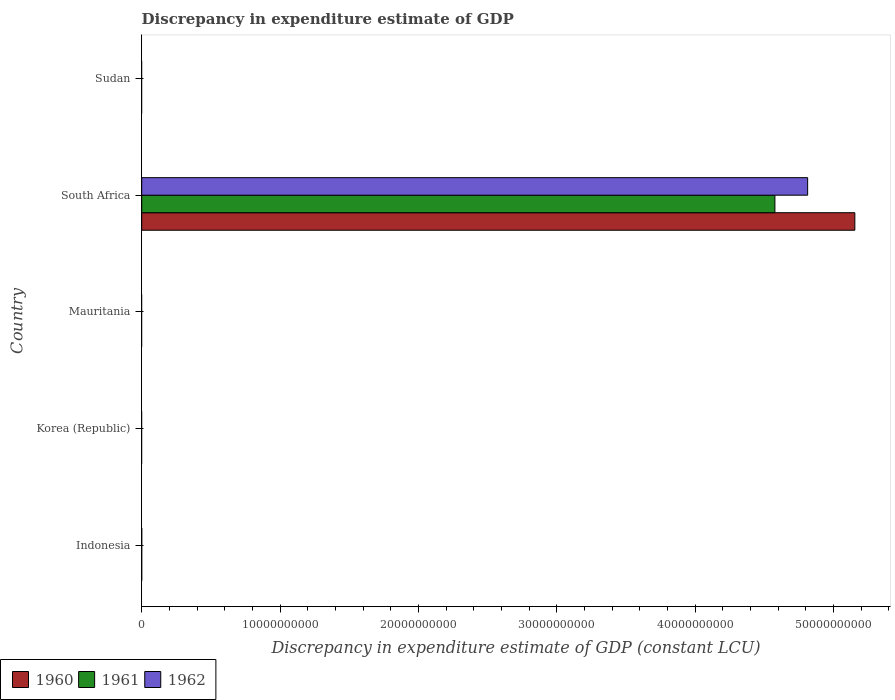How many bars are there on the 5th tick from the bottom?
Give a very brief answer. 0. In how many cases, is the number of bars for a given country not equal to the number of legend labels?
Your answer should be compact. 4. Across all countries, what is the maximum discrepancy in expenditure estimate of GDP in 1962?
Ensure brevity in your answer.  4.81e+1. In which country was the discrepancy in expenditure estimate of GDP in 1962 maximum?
Your answer should be compact. South Africa. What is the total discrepancy in expenditure estimate of GDP in 1962 in the graph?
Keep it short and to the point. 4.81e+1. What is the difference between the discrepancy in expenditure estimate of GDP in 1960 in South Africa and the discrepancy in expenditure estimate of GDP in 1961 in Korea (Republic)?
Ensure brevity in your answer.  5.15e+1. What is the average discrepancy in expenditure estimate of GDP in 1962 per country?
Provide a succinct answer. 9.62e+09. What is the difference between the discrepancy in expenditure estimate of GDP in 1961 and discrepancy in expenditure estimate of GDP in 1962 in South Africa?
Ensure brevity in your answer.  -2.37e+09. In how many countries, is the discrepancy in expenditure estimate of GDP in 1962 greater than 28000000000 LCU?
Your answer should be compact. 1. What is the difference between the highest and the lowest discrepancy in expenditure estimate of GDP in 1961?
Offer a very short reply. 4.58e+1. In how many countries, is the discrepancy in expenditure estimate of GDP in 1962 greater than the average discrepancy in expenditure estimate of GDP in 1962 taken over all countries?
Give a very brief answer. 1. Are all the bars in the graph horizontal?
Offer a terse response. Yes. How many countries are there in the graph?
Your answer should be compact. 5. What is the difference between two consecutive major ticks on the X-axis?
Provide a succinct answer. 1.00e+1. Are the values on the major ticks of X-axis written in scientific E-notation?
Offer a very short reply. No. Does the graph contain grids?
Provide a short and direct response. No. What is the title of the graph?
Your response must be concise. Discrepancy in expenditure estimate of GDP. Does "1971" appear as one of the legend labels in the graph?
Offer a terse response. No. What is the label or title of the X-axis?
Offer a very short reply. Discrepancy in expenditure estimate of GDP (constant LCU). What is the label or title of the Y-axis?
Offer a terse response. Country. What is the Discrepancy in expenditure estimate of GDP (constant LCU) of 1960 in Indonesia?
Provide a short and direct response. 0. What is the Discrepancy in expenditure estimate of GDP (constant LCU) of 1960 in Korea (Republic)?
Your answer should be very brief. 0. What is the Discrepancy in expenditure estimate of GDP (constant LCU) of 1962 in Korea (Republic)?
Ensure brevity in your answer.  0. What is the Discrepancy in expenditure estimate of GDP (constant LCU) in 1960 in Mauritania?
Your answer should be compact. 0. What is the Discrepancy in expenditure estimate of GDP (constant LCU) in 1960 in South Africa?
Provide a succinct answer. 5.15e+1. What is the Discrepancy in expenditure estimate of GDP (constant LCU) of 1961 in South Africa?
Your answer should be compact. 4.58e+1. What is the Discrepancy in expenditure estimate of GDP (constant LCU) in 1962 in South Africa?
Provide a short and direct response. 4.81e+1. What is the Discrepancy in expenditure estimate of GDP (constant LCU) in 1961 in Sudan?
Make the answer very short. 0. Across all countries, what is the maximum Discrepancy in expenditure estimate of GDP (constant LCU) in 1960?
Your answer should be very brief. 5.15e+1. Across all countries, what is the maximum Discrepancy in expenditure estimate of GDP (constant LCU) of 1961?
Your response must be concise. 4.58e+1. Across all countries, what is the maximum Discrepancy in expenditure estimate of GDP (constant LCU) in 1962?
Offer a very short reply. 4.81e+1. Across all countries, what is the minimum Discrepancy in expenditure estimate of GDP (constant LCU) in 1961?
Make the answer very short. 0. What is the total Discrepancy in expenditure estimate of GDP (constant LCU) of 1960 in the graph?
Provide a succinct answer. 5.15e+1. What is the total Discrepancy in expenditure estimate of GDP (constant LCU) in 1961 in the graph?
Offer a terse response. 4.58e+1. What is the total Discrepancy in expenditure estimate of GDP (constant LCU) in 1962 in the graph?
Give a very brief answer. 4.81e+1. What is the average Discrepancy in expenditure estimate of GDP (constant LCU) of 1960 per country?
Provide a short and direct response. 1.03e+1. What is the average Discrepancy in expenditure estimate of GDP (constant LCU) in 1961 per country?
Your answer should be compact. 9.15e+09. What is the average Discrepancy in expenditure estimate of GDP (constant LCU) in 1962 per country?
Your response must be concise. 9.62e+09. What is the difference between the Discrepancy in expenditure estimate of GDP (constant LCU) of 1960 and Discrepancy in expenditure estimate of GDP (constant LCU) of 1961 in South Africa?
Offer a terse response. 5.78e+09. What is the difference between the Discrepancy in expenditure estimate of GDP (constant LCU) of 1960 and Discrepancy in expenditure estimate of GDP (constant LCU) of 1962 in South Africa?
Offer a very short reply. 3.41e+09. What is the difference between the Discrepancy in expenditure estimate of GDP (constant LCU) in 1961 and Discrepancy in expenditure estimate of GDP (constant LCU) in 1962 in South Africa?
Your response must be concise. -2.37e+09. What is the difference between the highest and the lowest Discrepancy in expenditure estimate of GDP (constant LCU) of 1960?
Give a very brief answer. 5.15e+1. What is the difference between the highest and the lowest Discrepancy in expenditure estimate of GDP (constant LCU) of 1961?
Provide a succinct answer. 4.58e+1. What is the difference between the highest and the lowest Discrepancy in expenditure estimate of GDP (constant LCU) in 1962?
Your answer should be very brief. 4.81e+1. 